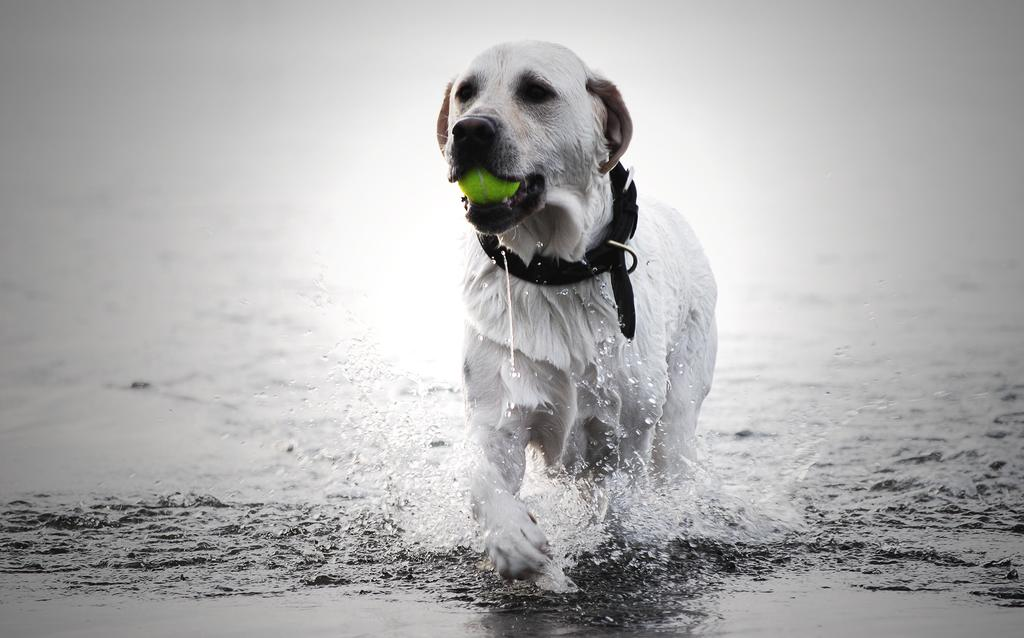What is the color scheme of the image? The image is black and white. What is the main subject of the picture? There is a dog in the center of the picture. What is the dog doing in the image? The dog is holding a ball. Where is the dog located in the image? The dog is in the water. What type of clover can be seen growing near the dog in the image? There is no clover present in the image; it is a black and white picture of a dog holding a ball in the water. 